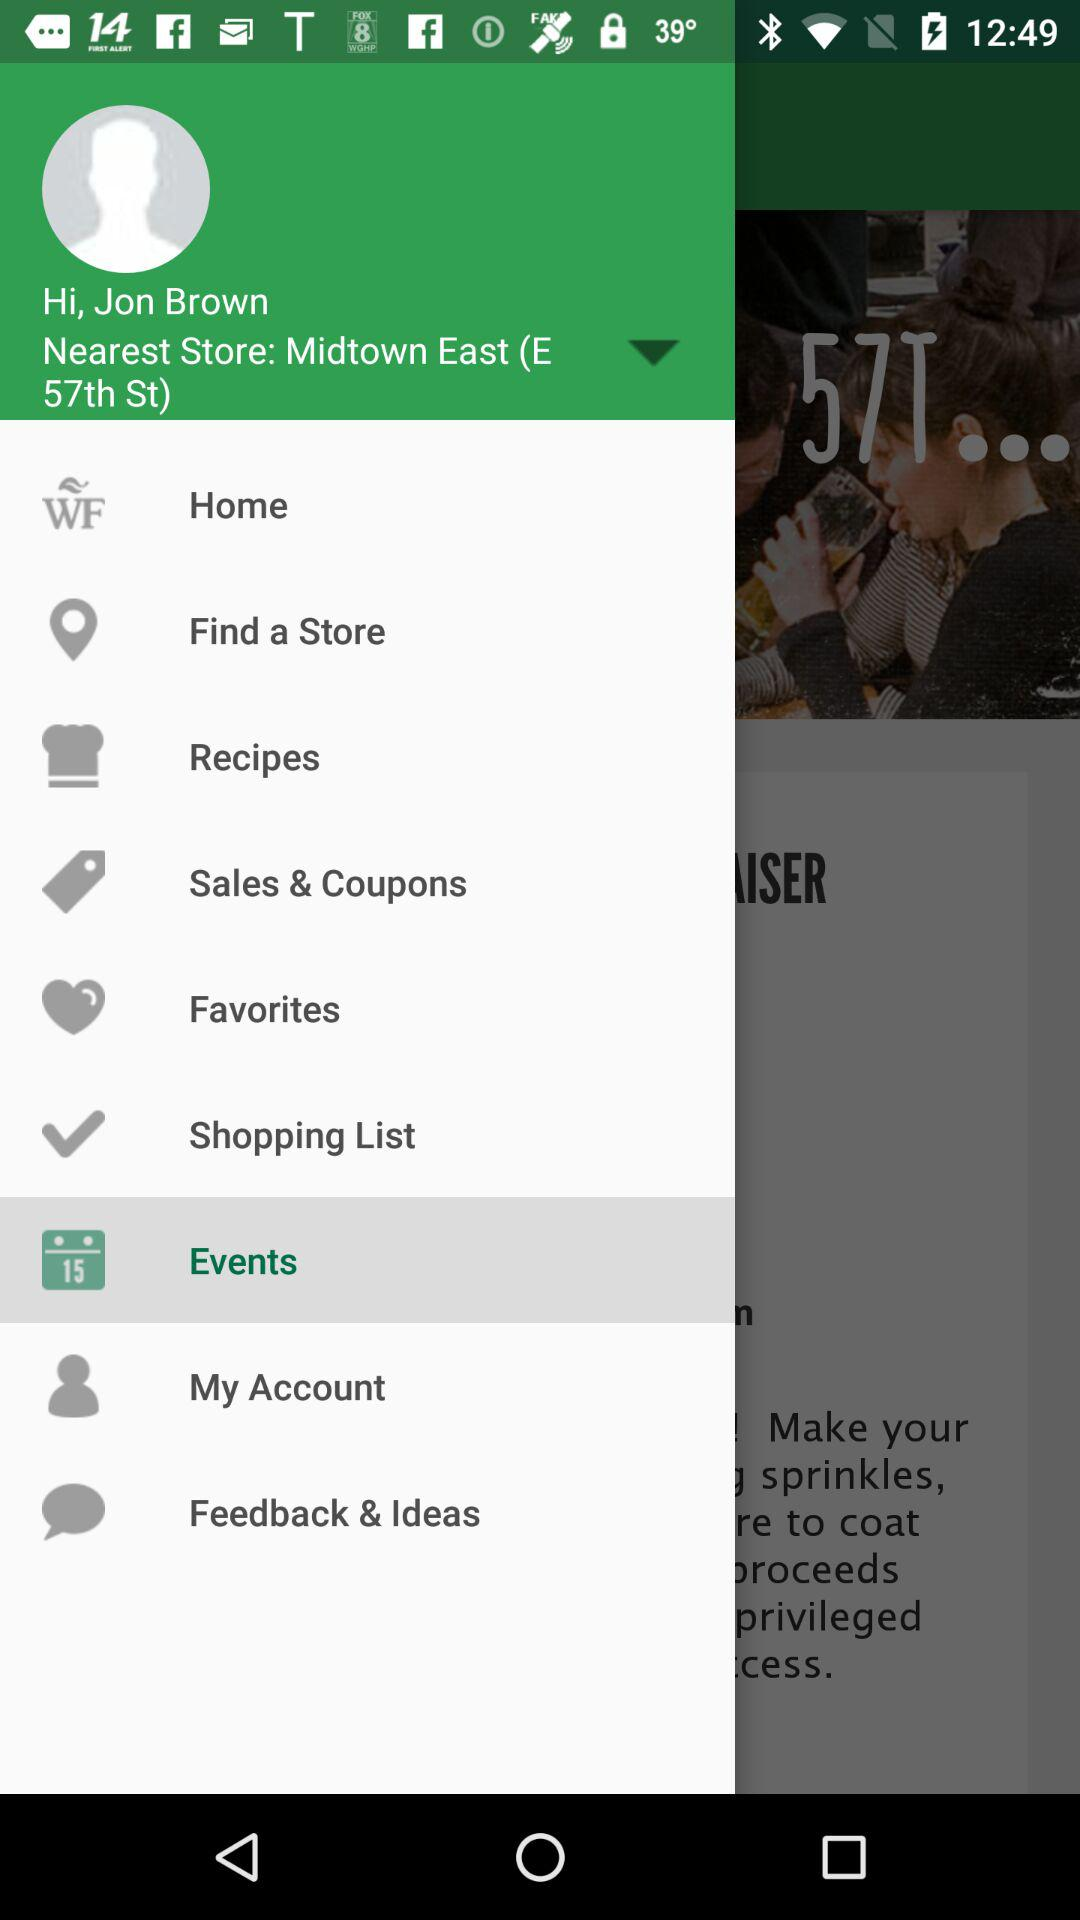What is the selected item? The selected item is "Events". 